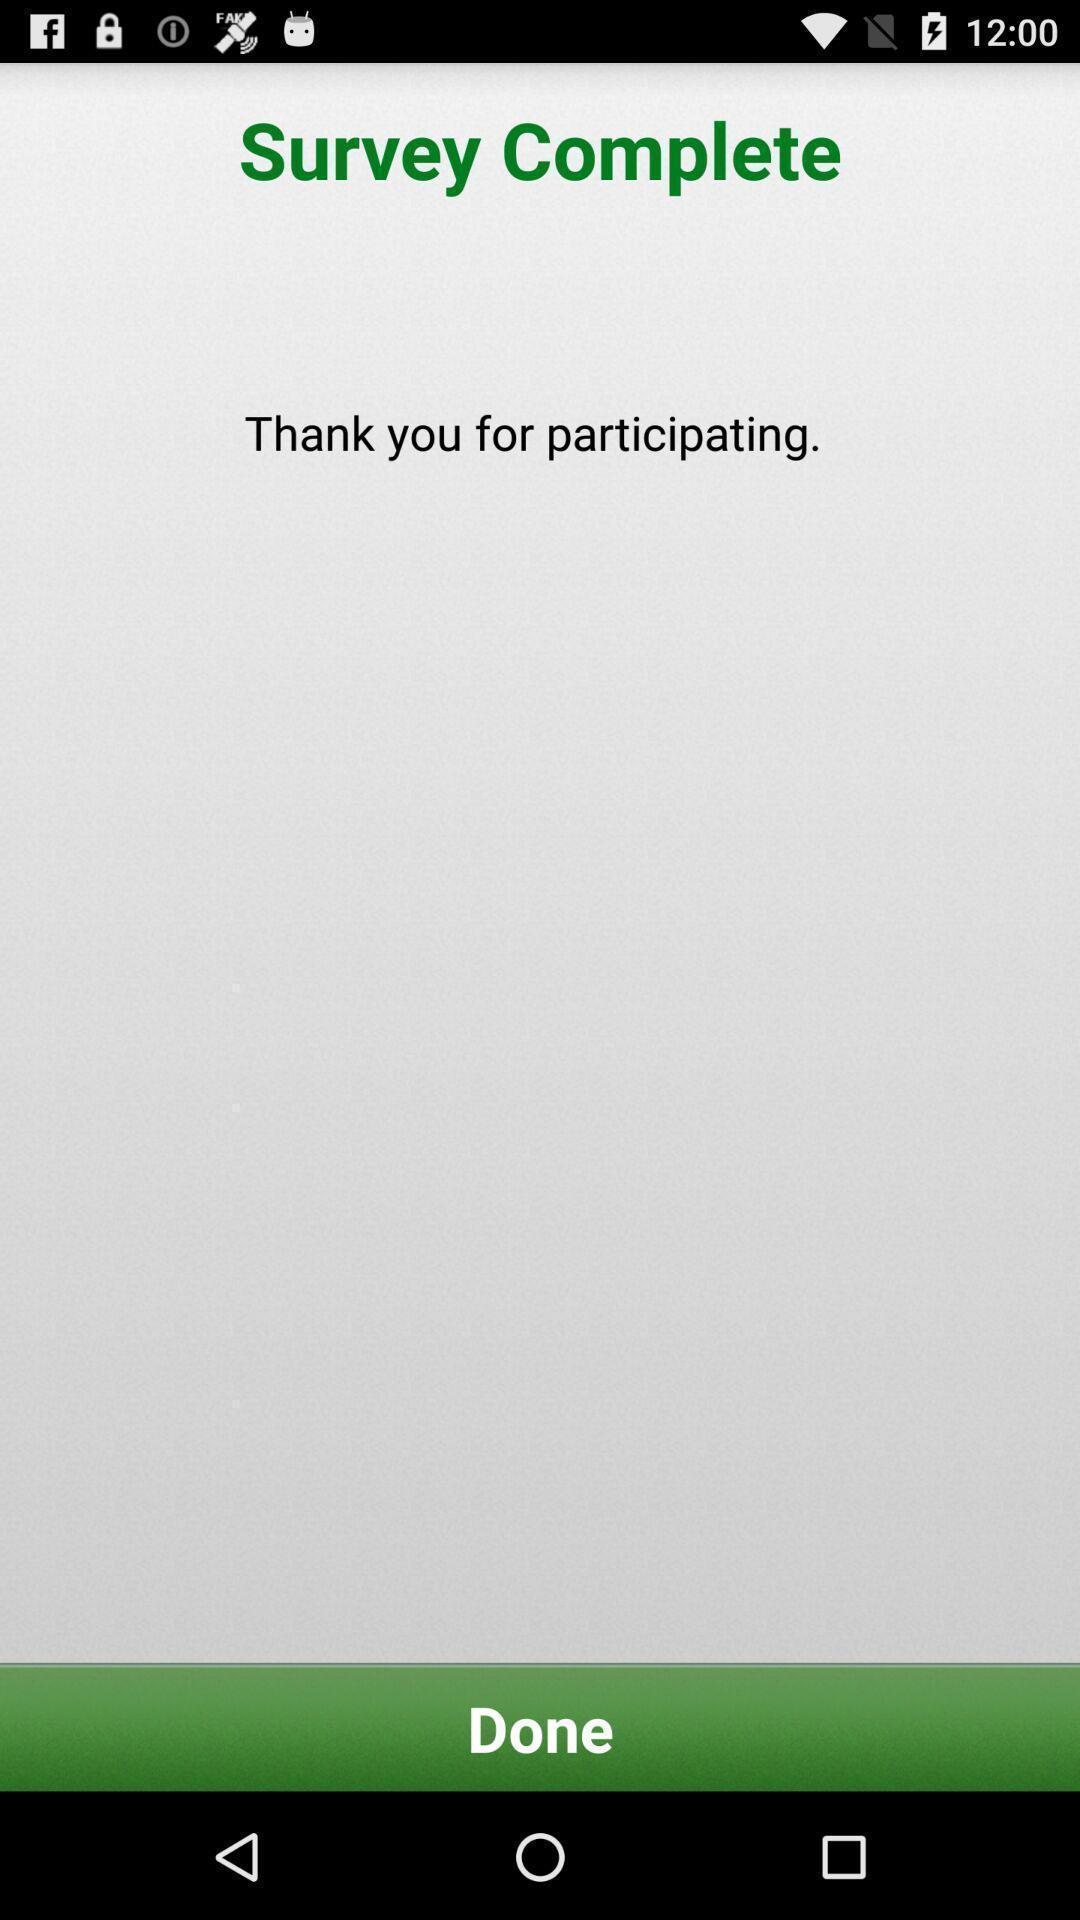Provide a detailed account of this screenshot. Screen shows survey status page. 